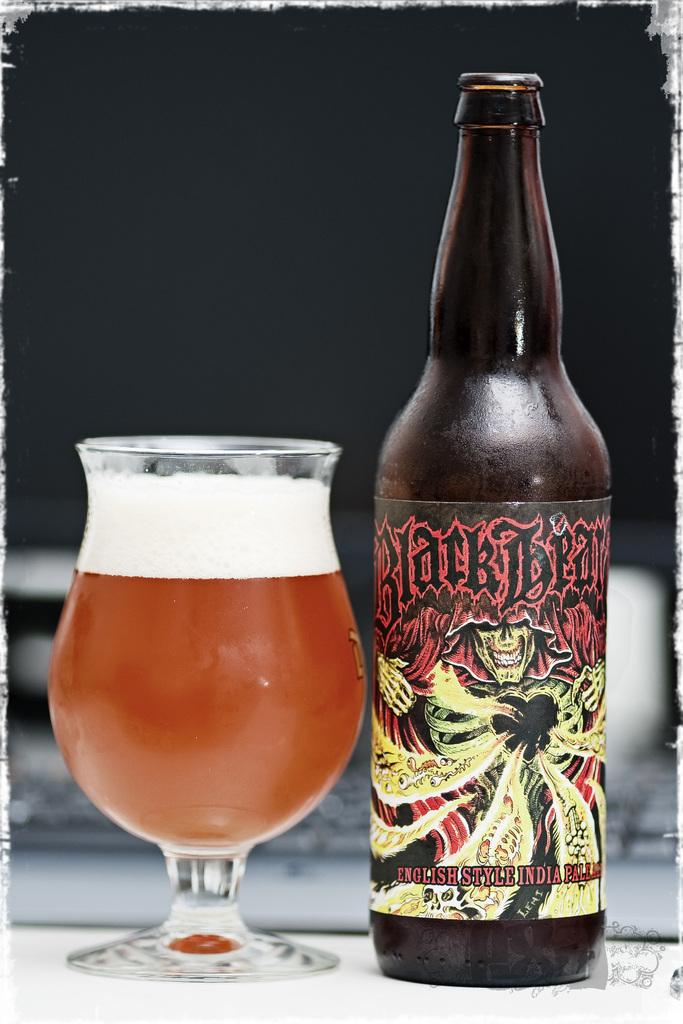<image>
Summarize the visual content of the image. a bottle of black bear beer has been poured into a glass 